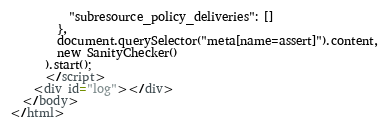<code> <loc_0><loc_0><loc_500><loc_500><_HTML_>          "subresource_policy_deliveries": []
        },
        document.querySelector("meta[name=assert]").content,
        new SanityChecker()
      ).start();
      </script>
    <div id="log"></div>
  </body>
</html>
</code> 